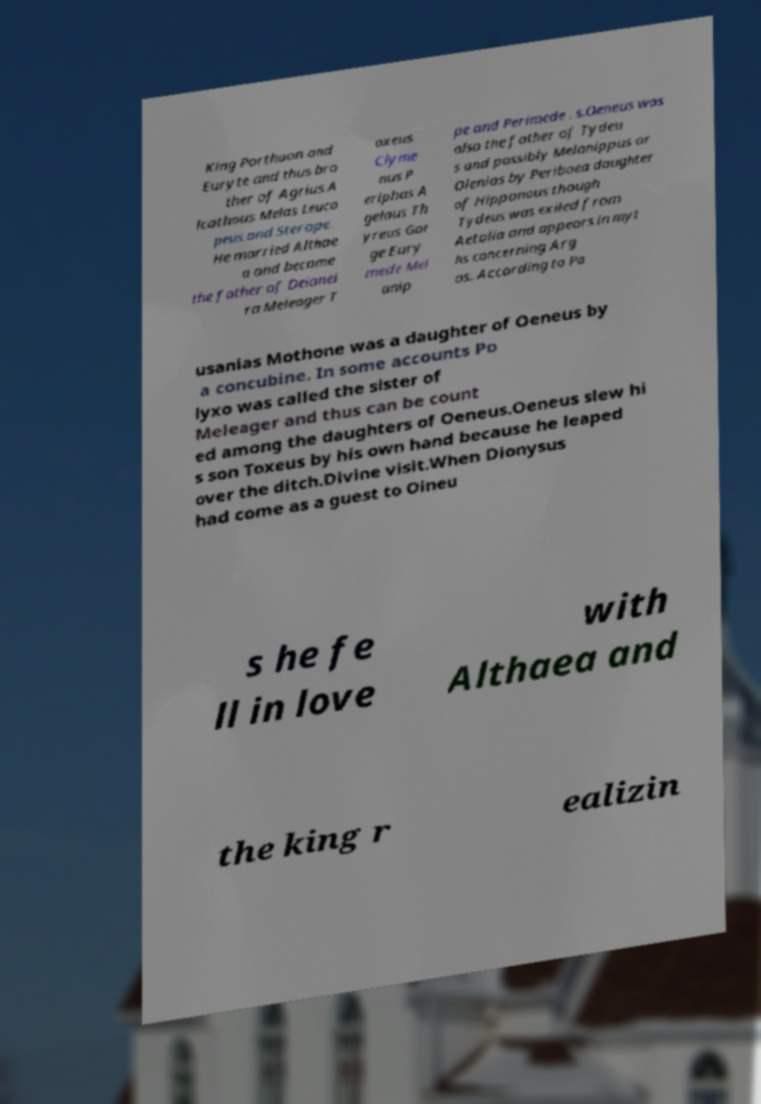Could you extract and type out the text from this image? King Porthaon and Euryte and thus bro ther of Agrius A lcathous Melas Leuco peus and Sterope. He married Althae a and became the father of Deianei ra Meleager T oxeus Clyme nus P eriphas A gelaus Th yreus Gor ge Eury mede Mel anip pe and Perimede . s.Oeneus was also the father of Tydeu s and possibly Melanippus or Olenias by Periboea daughter of Hipponous though Tydeus was exiled from Aetolia and appears in myt hs concerning Arg os. According to Pa usanias Mothone was a daughter of Oeneus by a concubine. In some accounts Po lyxo was called the sister of Meleager and thus can be count ed among the daughters of Oeneus.Oeneus slew hi s son Toxeus by his own hand because he leaped over the ditch.Divine visit.When Dionysus had come as a guest to Oineu s he fe ll in love with Althaea and the king r ealizin 